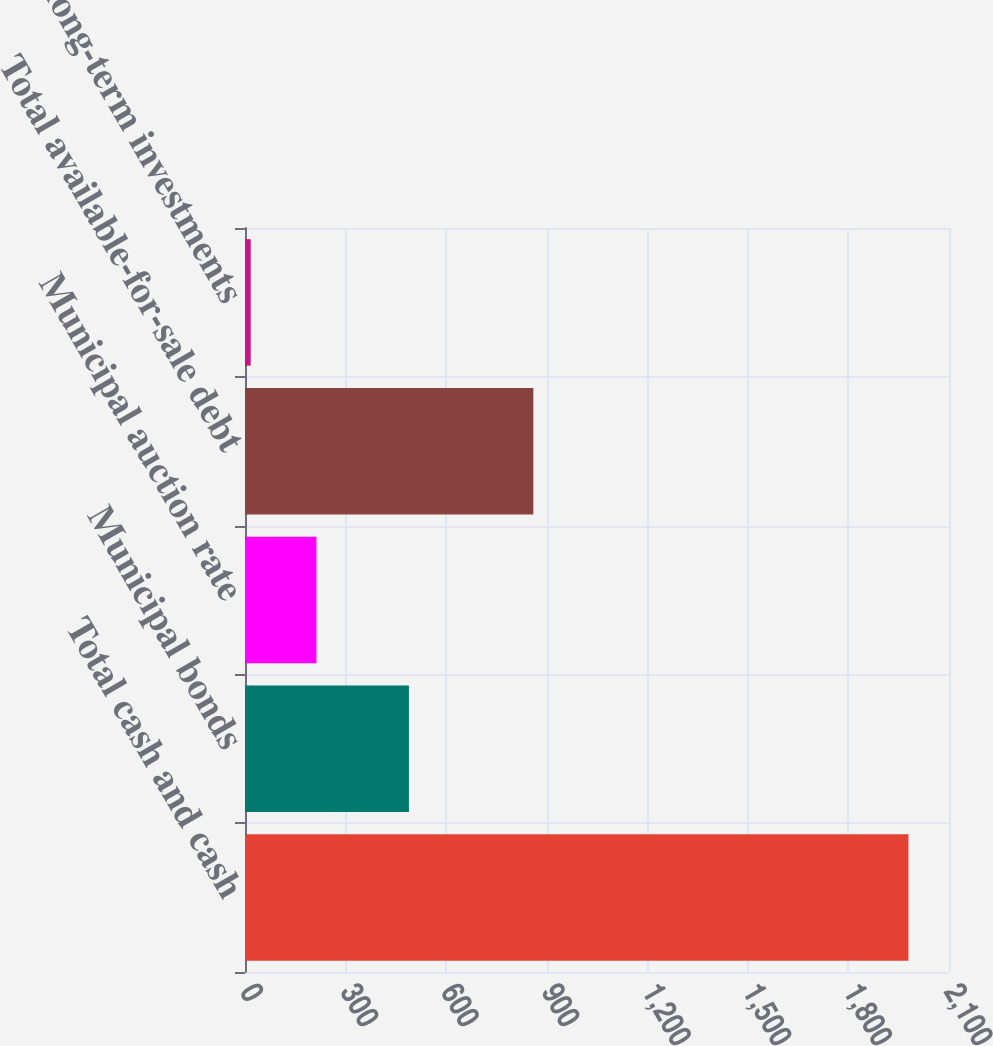Convert chart to OTSL. <chart><loc_0><loc_0><loc_500><loc_500><bar_chart><fcel>Total cash and cash<fcel>Municipal bonds<fcel>Municipal auction rate<fcel>Total available-for-sale debt<fcel>Other long-term investments<nl><fcel>1979<fcel>489<fcel>213.2<fcel>860<fcel>17<nl></chart> 